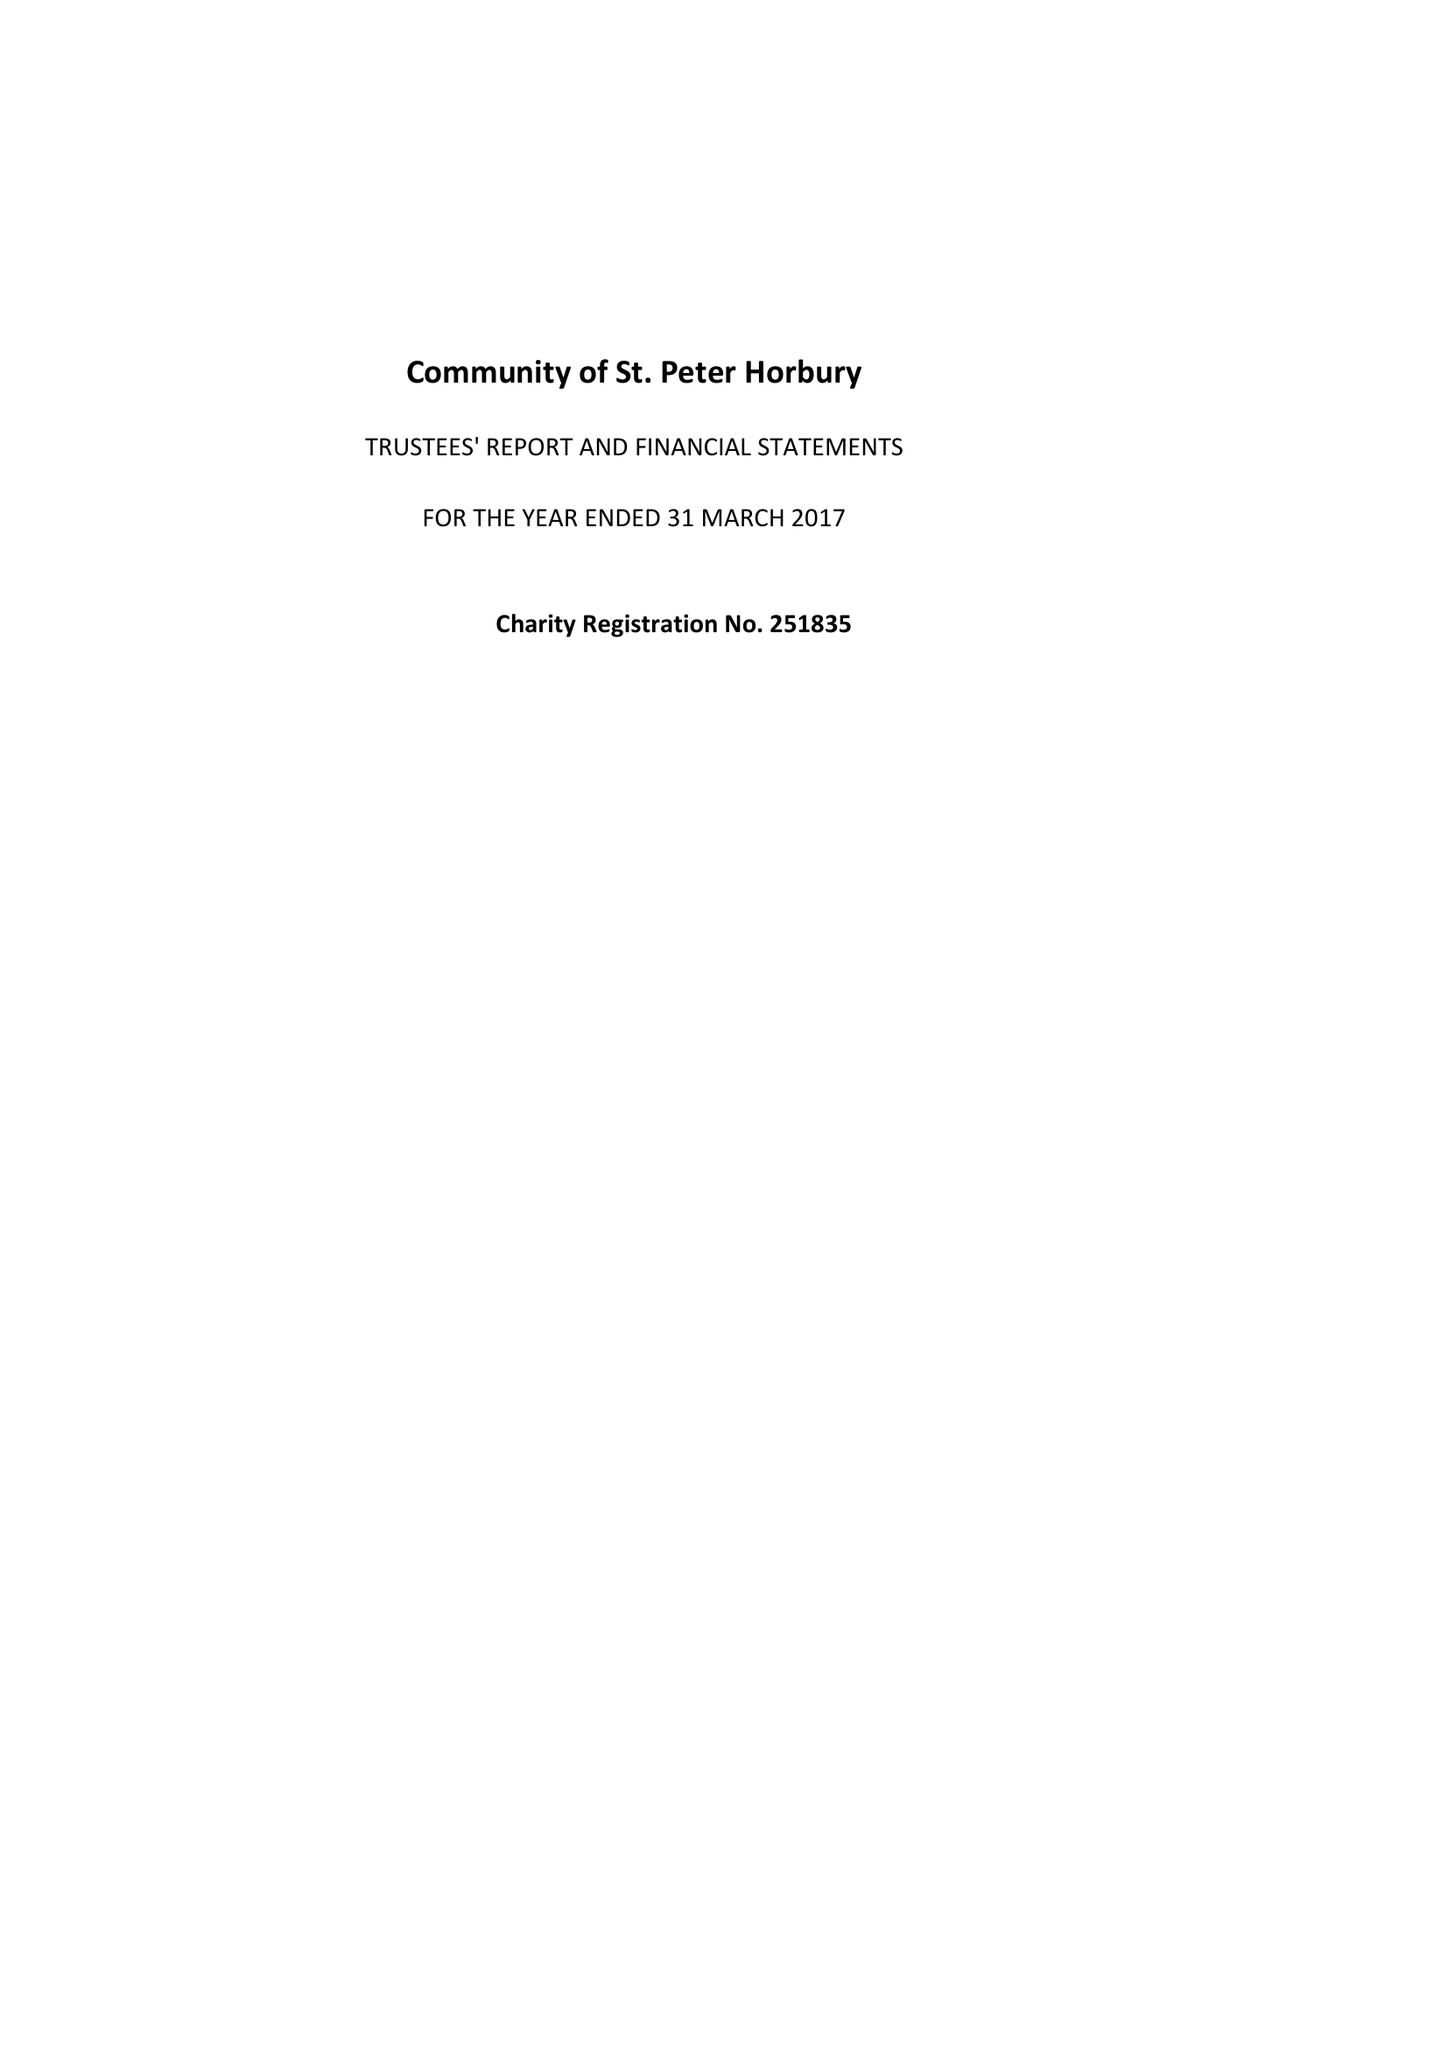What is the value for the charity_name?
Answer the question using a single word or phrase. Community Of St Peter Horbury 